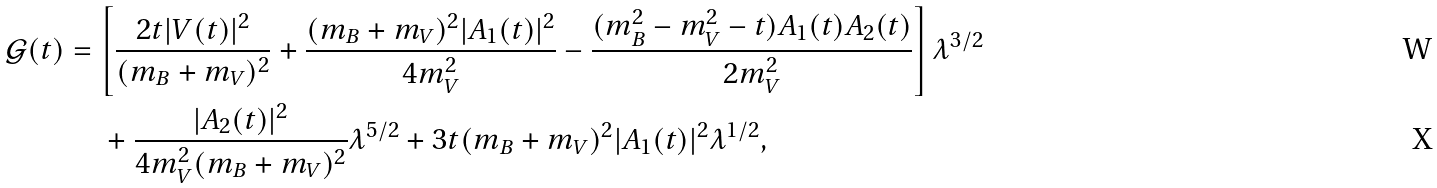<formula> <loc_0><loc_0><loc_500><loc_500>\mathcal { G } ( t ) = \, & \left [ \frac { 2 t | V ( t ) | ^ { 2 } } { ( m _ { B } + m _ { V } ) ^ { 2 } } + \frac { ( m _ { B } + m _ { V } ) ^ { 2 } | A _ { 1 } ( t ) | ^ { 2 } } { 4 m _ { V } ^ { 2 } } - \frac { ( m _ { B } ^ { 2 } - m _ { V } ^ { 2 } - t ) A _ { 1 } ( t ) A _ { 2 } ( t ) } { 2 m _ { V } ^ { 2 } } \right ] \lambda ^ { 3 / 2 } \\ & \, + \frac { | A _ { 2 } ( t ) | ^ { 2 } } { 4 m _ { V } ^ { 2 } ( m _ { B } + m _ { V } ) ^ { 2 } } \lambda ^ { 5 / 2 } + 3 t ( m _ { B } + m _ { V } ) ^ { 2 } | A _ { 1 } ( t ) | ^ { 2 } \lambda ^ { 1 / 2 } ,</formula> 